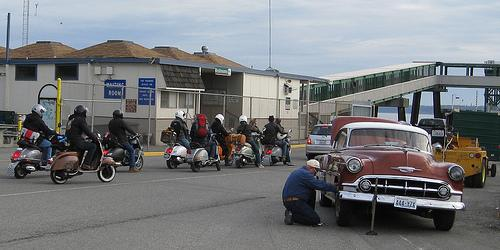Provide a one-sentence summary of the core action occurring in the image. A man is changing a tire on his classic car while several motorcyclists pass by on a street with a cloudy sky background. List three most prominent objects in the image along with their colors. Red classic car under repair, brown motorbike, and man with blue shirt. Can you identify the specific focus of the image in relation to human activity? The specific focus is a man wearing a blue shirt and white cap, kneeling and changing the tire of his classic car. In a sentence, describe some prominent transport vehicles in the picture. There is a red classic car undergoing repairs, a brown motorbike, and a yellow car trailer. What is the condition of the car being repaired, and what is the repairman doing? The car is an older, possibly classic, red car being repaired by a man who is using a metal car jack to change a tire. Comment on the setting of the image by mentioning the surroundings and the overall scenario. The image is set on a street with a group of motorcyclists riding, a man repairing his car, brown triangular rooftops in the background, and the sky is cloudy. Describe the weather and road conditions in the image. The weather is mostly cloudy with a blue sky, and the asphalt road appears to be dry. Briefly describe the attire of the man repairing the car. The man is wearing a blue long sleeve shirt, possibly a white cap, and has a brown belt. What are the people doing in the image? Are they wearing any protective gear? People are riding motorcycles, most of them are wearing helmets, and a man is fixing his car's tire. List any noticeable or stand-out colors you see in the image. Black helmets, blue shirt, brown motorbike, red classic car, yellow car trailer, blue sign, and white helmet. Notice the wet asphalt surface. The asphalt is described as dry, not wet, making this instruction misleading. Observe the clear, cloudless sky in the image. The sky in the image is described as cloudy or having white ripples of clouds, so this instruction is misleading. The cars license plate is blue. No, it's not mentioned in the image. The man is standing up while fixing the car. This statement is false because the man is kneeling, not standing, while fixing the car. Spot the small red car in the scene. There is no small red car; there's a red classic car in the image which is misleading. Are the helmets white in color? This question is deceptive because the helmets are described as black, not white. Find the orange motorcycle among the vehicles. This instruction is misleading because the motorcycle in the image is brown, not orange. Does the man wear a purple cap? The instruction is false since the man is actually wearing a white cap. Is the man wearing a green shirt? The instruction is incorrect because the man is actually wearing a blue shirt. 